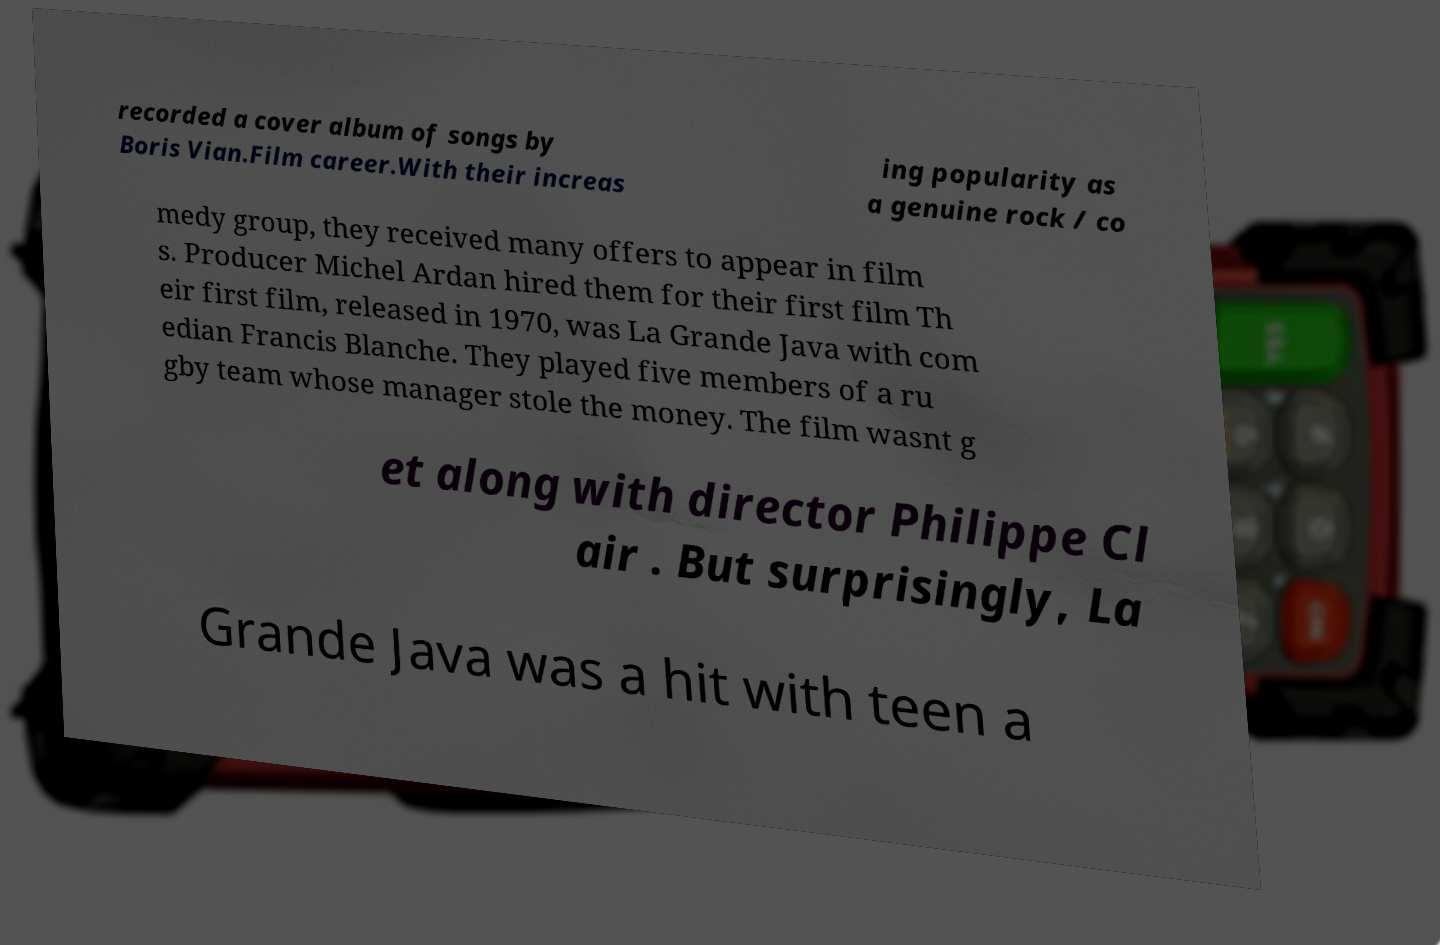What messages or text are displayed in this image? I need them in a readable, typed format. recorded a cover album of songs by Boris Vian.Film career.With their increas ing popularity as a genuine rock / co medy group, they received many offers to appear in film s. Producer Michel Ardan hired them for their first film Th eir first film, released in 1970, was La Grande Java with com edian Francis Blanche. They played five members of a ru gby team whose manager stole the money. The film wasnt g et along with director Philippe Cl air . But surprisingly, La Grande Java was a hit with teen a 